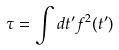<formula> <loc_0><loc_0><loc_500><loc_500>\tau = \int d t ^ { \prime } f ^ { 2 } ( t ^ { \prime } )</formula> 